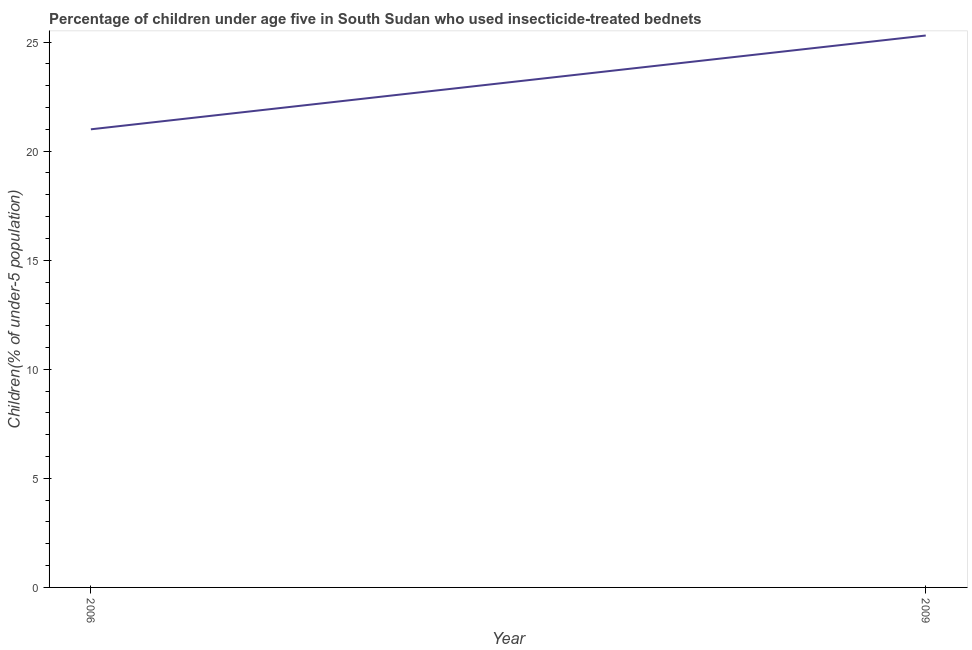What is the percentage of children who use of insecticide-treated bed nets in 2006?
Provide a short and direct response. 21. Across all years, what is the maximum percentage of children who use of insecticide-treated bed nets?
Offer a terse response. 25.3. Across all years, what is the minimum percentage of children who use of insecticide-treated bed nets?
Offer a terse response. 21. In which year was the percentage of children who use of insecticide-treated bed nets maximum?
Provide a short and direct response. 2009. What is the sum of the percentage of children who use of insecticide-treated bed nets?
Your response must be concise. 46.3. What is the difference between the percentage of children who use of insecticide-treated bed nets in 2006 and 2009?
Give a very brief answer. -4.3. What is the average percentage of children who use of insecticide-treated bed nets per year?
Ensure brevity in your answer.  23.15. What is the median percentage of children who use of insecticide-treated bed nets?
Keep it short and to the point. 23.15. In how many years, is the percentage of children who use of insecticide-treated bed nets greater than 23 %?
Ensure brevity in your answer.  1. Do a majority of the years between 2009 and 2006 (inclusive) have percentage of children who use of insecticide-treated bed nets greater than 22 %?
Provide a short and direct response. No. What is the ratio of the percentage of children who use of insecticide-treated bed nets in 2006 to that in 2009?
Your answer should be very brief. 0.83. In how many years, is the percentage of children who use of insecticide-treated bed nets greater than the average percentage of children who use of insecticide-treated bed nets taken over all years?
Make the answer very short. 1. Does the percentage of children who use of insecticide-treated bed nets monotonically increase over the years?
Your response must be concise. Yes. How many lines are there?
Your answer should be compact. 1. How many years are there in the graph?
Your answer should be very brief. 2. What is the difference between two consecutive major ticks on the Y-axis?
Make the answer very short. 5. Does the graph contain any zero values?
Your answer should be very brief. No. What is the title of the graph?
Keep it short and to the point. Percentage of children under age five in South Sudan who used insecticide-treated bednets. What is the label or title of the X-axis?
Give a very brief answer. Year. What is the label or title of the Y-axis?
Ensure brevity in your answer.  Children(% of under-5 population). What is the Children(% of under-5 population) of 2009?
Give a very brief answer. 25.3. What is the ratio of the Children(% of under-5 population) in 2006 to that in 2009?
Make the answer very short. 0.83. 